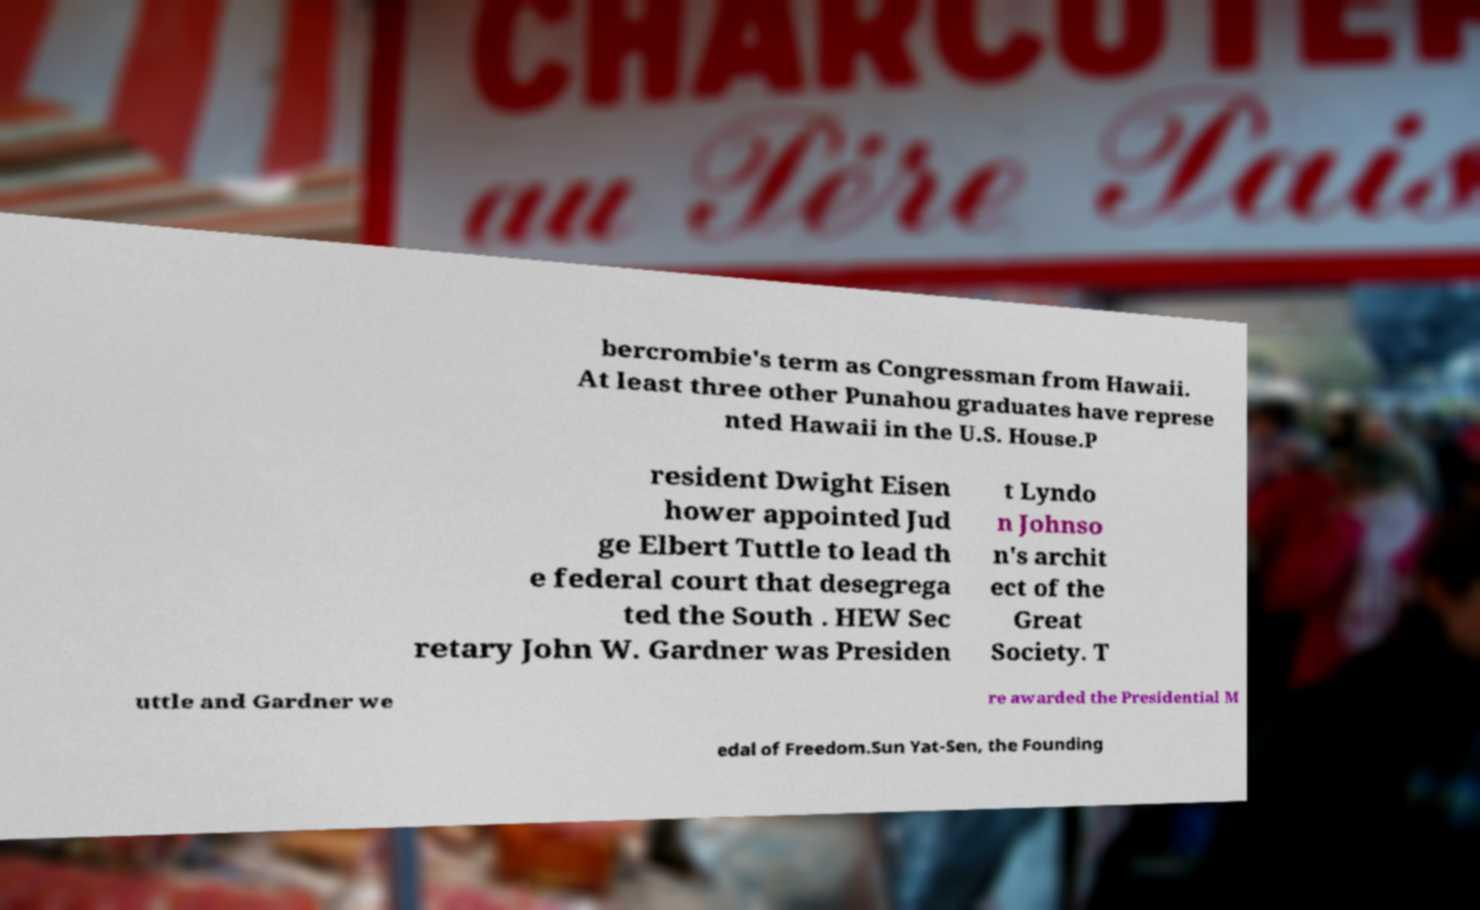Please read and relay the text visible in this image. What does it say? bercrombie's term as Congressman from Hawaii. At least three other Punahou graduates have represe nted Hawaii in the U.S. House.P resident Dwight Eisen hower appointed Jud ge Elbert Tuttle to lead th e federal court that desegrega ted the South . HEW Sec retary John W. Gardner was Presiden t Lyndo n Johnso n's archit ect of the Great Society. T uttle and Gardner we re awarded the Presidential M edal of Freedom.Sun Yat-Sen, the Founding 